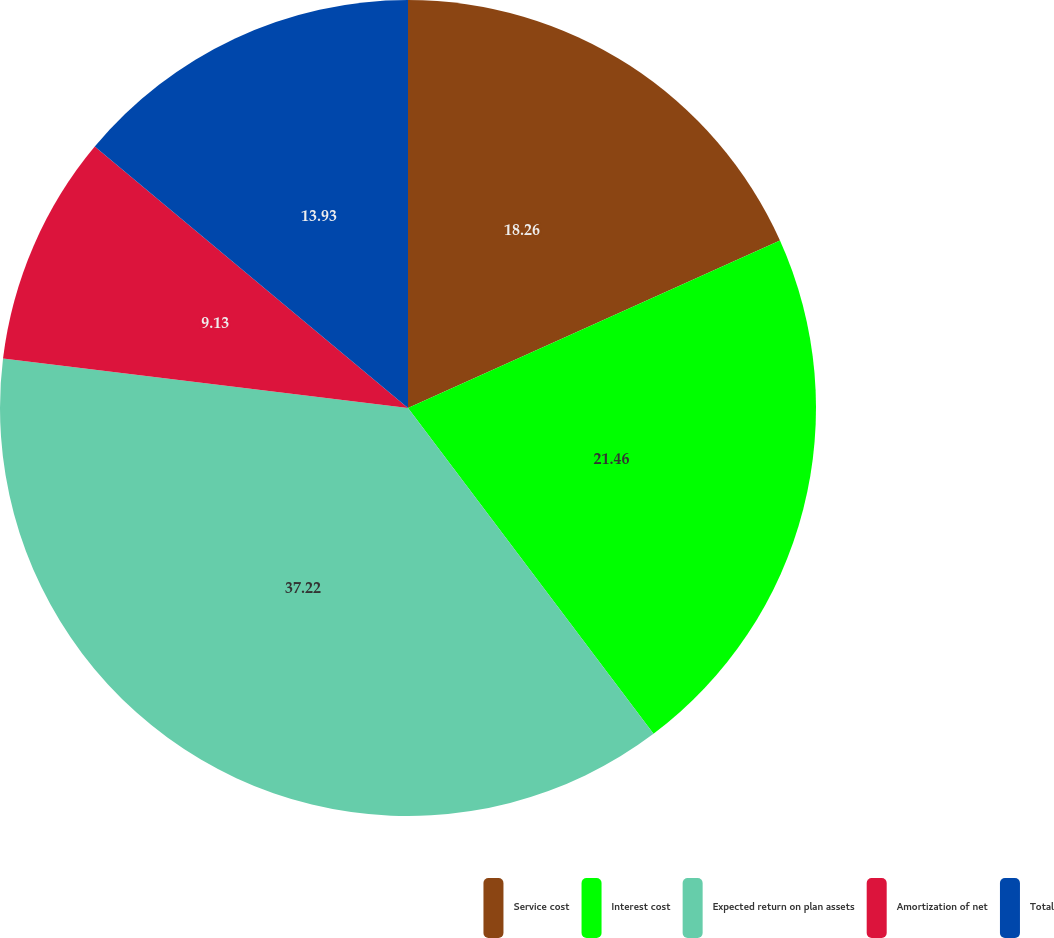Convert chart. <chart><loc_0><loc_0><loc_500><loc_500><pie_chart><fcel>Service cost<fcel>Interest cost<fcel>Expected return on plan assets<fcel>Amortization of net<fcel>Total<nl><fcel>18.26%<fcel>21.46%<fcel>37.21%<fcel>9.13%<fcel>13.93%<nl></chart> 